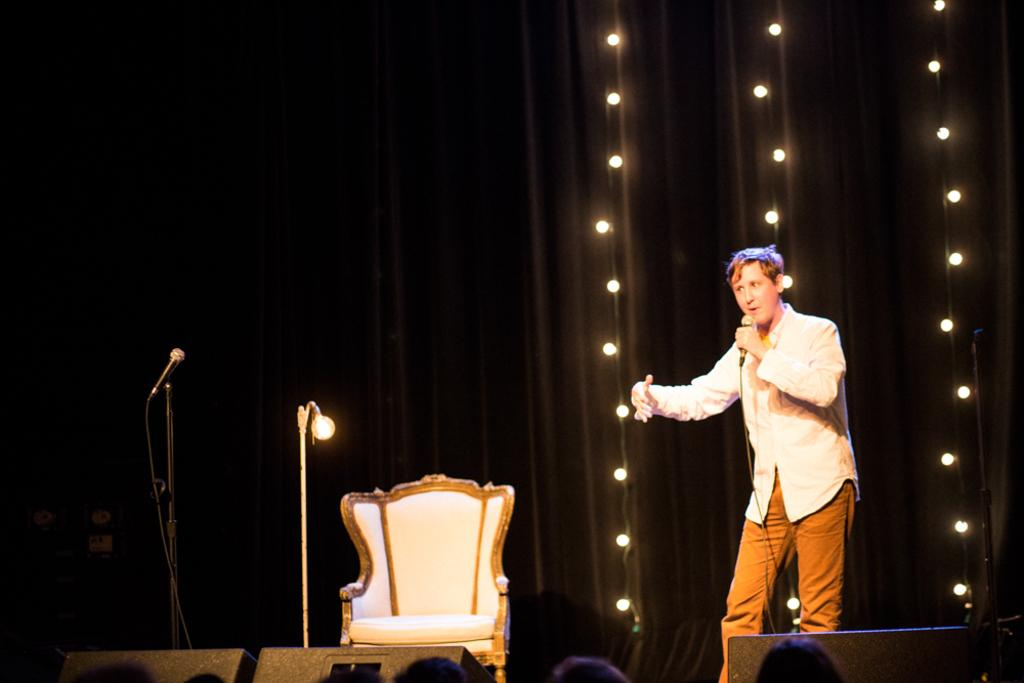Who is present in the image? There is a man in the image. What is the man doing in the image? The man is standing and holding a mic. What else can be seen in the image besides the man? There is a chair, another mic, and lights visible in the background of the image. What type of bird is sitting on the lettuce in the image? There is no bird or lettuce present in the image. 